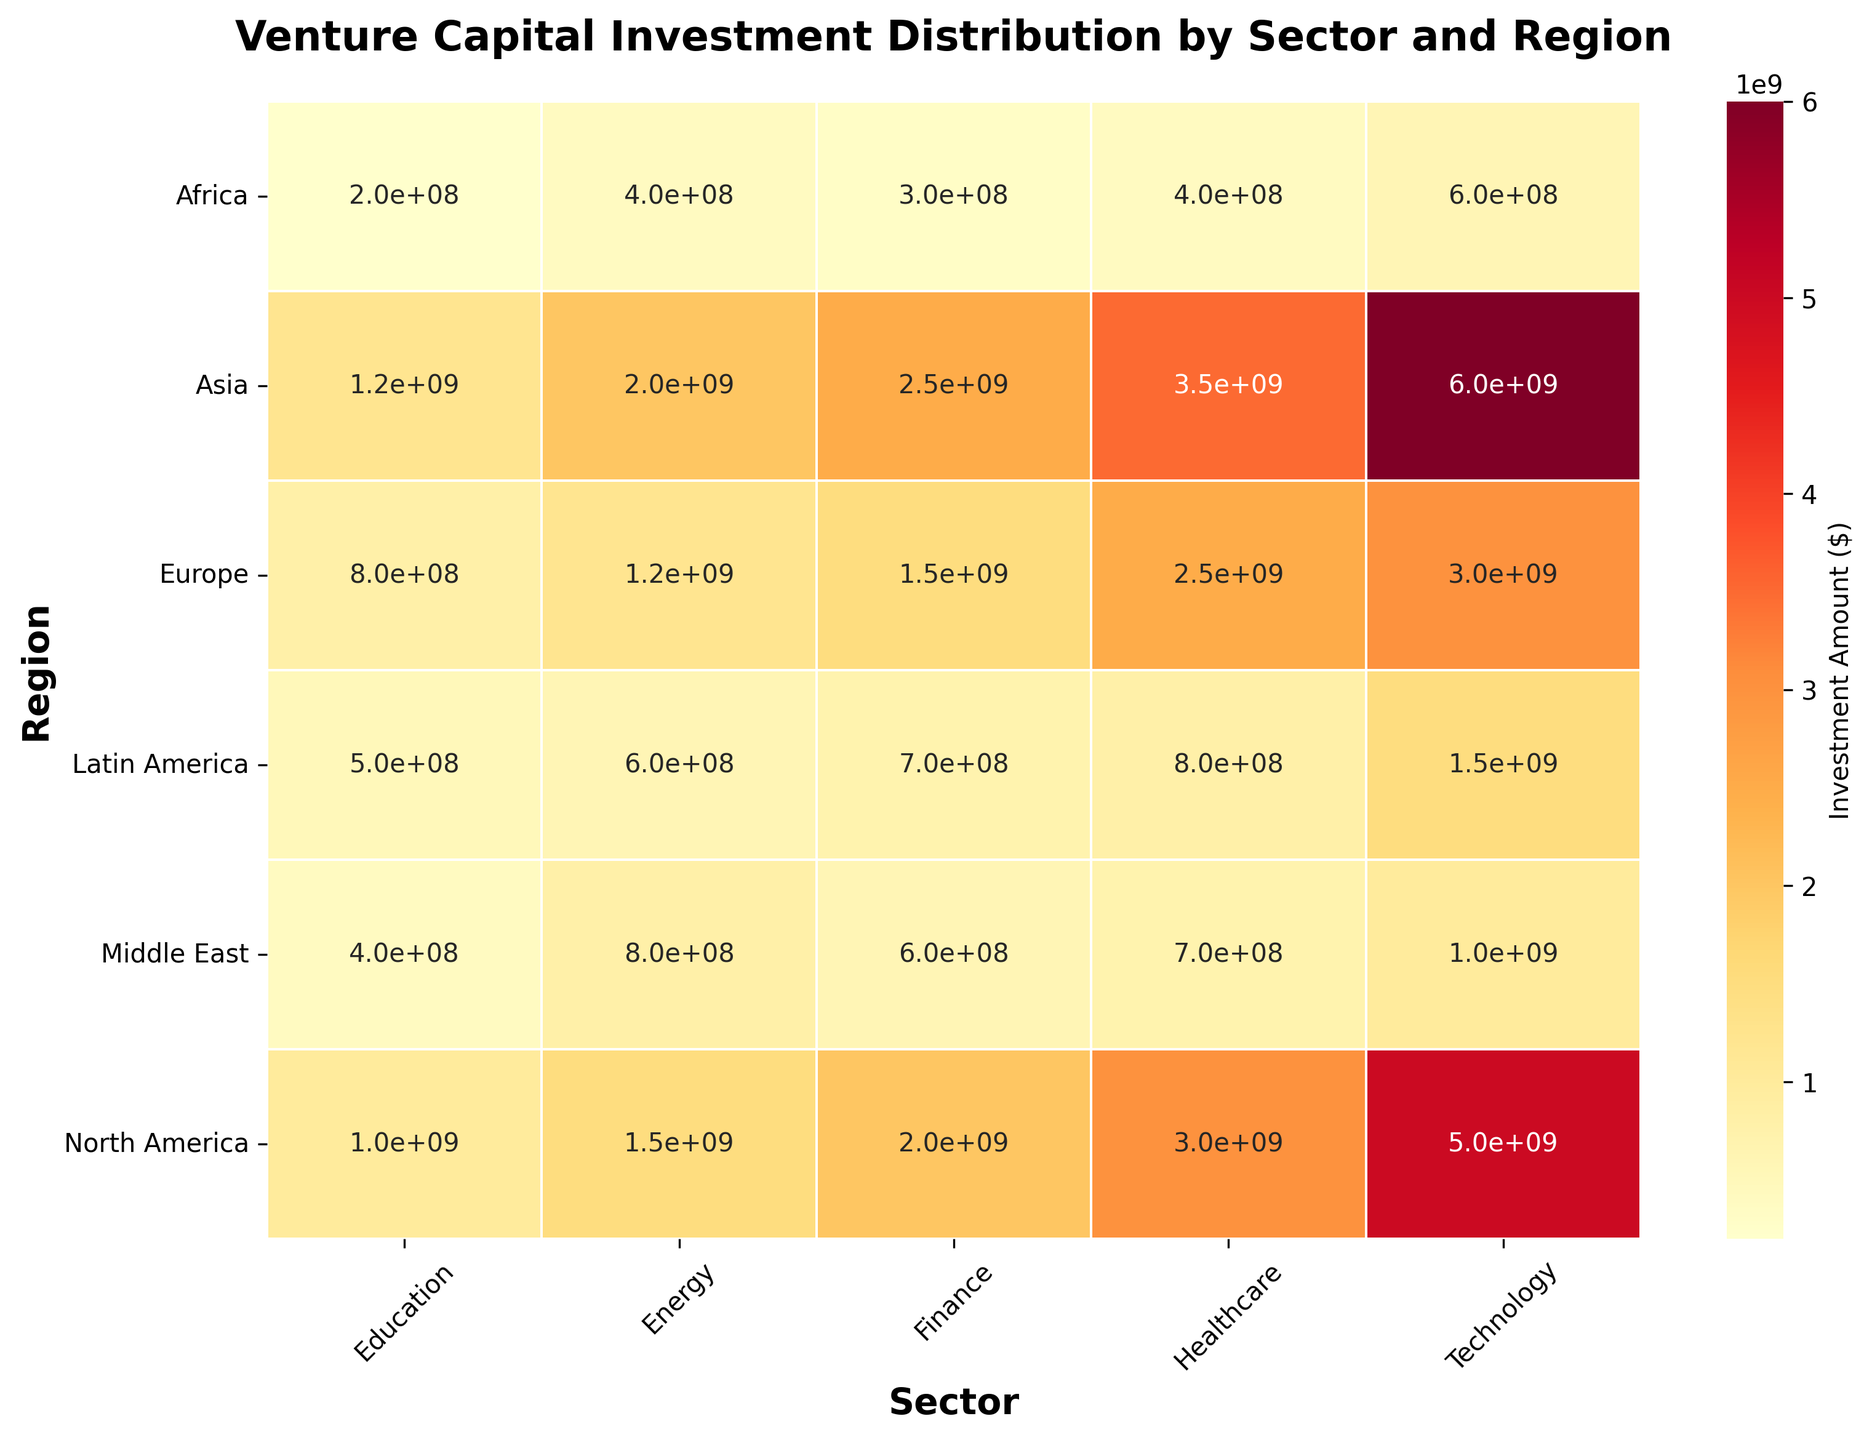Which region has the highest venture capital investment in the Technology sector? By examining the heatmap, we can identify the region with the darkest/red color in the Technology column, which signifies the highest investment amount. Asia has the highest investment in the Technology sector.
Answer: Asia What is the total venture capital investment in Healthcare across all regions? We can add up the investment amounts in the Healthcare sector across all the regions: 3000000000 (North America) + 2500000000 (Europe) + 3500000000 (Asia) + 800000000 (Latin America) + 700000000 (Middle East) + 400000000 (Africa) = 10900000000.
Answer: 10900000000 Which sector has the least total investment in Latin America? By examining the Latin America row, we can identify the sector with the lightest color/lowest value. Education has the least investment at 500000000.
Answer: Education Compare the venture capital investments between the Healthcare and Finance sectors in North America. Which sector has more investment and by how much? In North America, the investment amount for Healthcare is 3000000000 and for Finance, it is 2000000000. The Healthcare sector has 1000000000 more investment than the Finance sector.
Answer: Healthcare; 1000000000 Visual question: Which region has the most uniform distribution of venture capital investments across different sectors? We can identify the region where the colors are the most similar (uniform) across the row. Europe has relatively uniform investment amounts across its sectors compared to other regions.
Answer: Europe What is the combined investment amount in the Technology sector for North America, Europe, and Asia? We sum the investment amounts in the Technology sector for these three regions: 5000000000 (North America) + 3000000000 (Europe) + 6000000000 (Asia) = 14000000000.
Answer: 14000000000 In which sector does Africa receive more investment than Latin America, and how much more investment does it receive? Comparing the investments in Africa and Latin America across all sectors, Africa receives more investment in the Energy sector. Africa has 400000000, while Latin America has 600000000. The difference is 200000000.
Answer: Energy; 200000000 What is the average investment amount in the Finance sector across all regions? To find the average, sum the investments in the Finance sector across all regions and then divide by the number of regions: (2000000000 + 1500000000 + 2500000000 + 700000000 + 600000000 + 300000000) / 6 = 1266666666.67.
Answer: 1266666666.67 